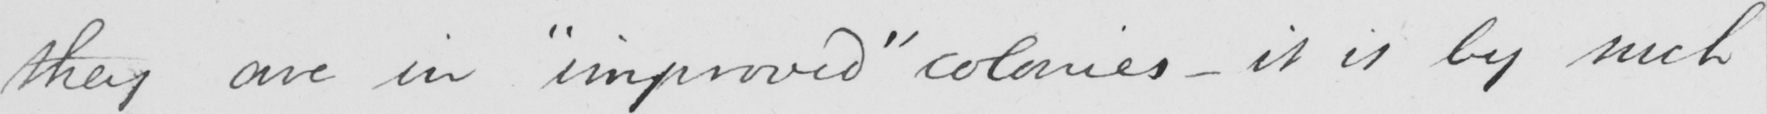Transcribe the text shown in this historical manuscript line. they are in  " improved "  colonies  _  it is by such 